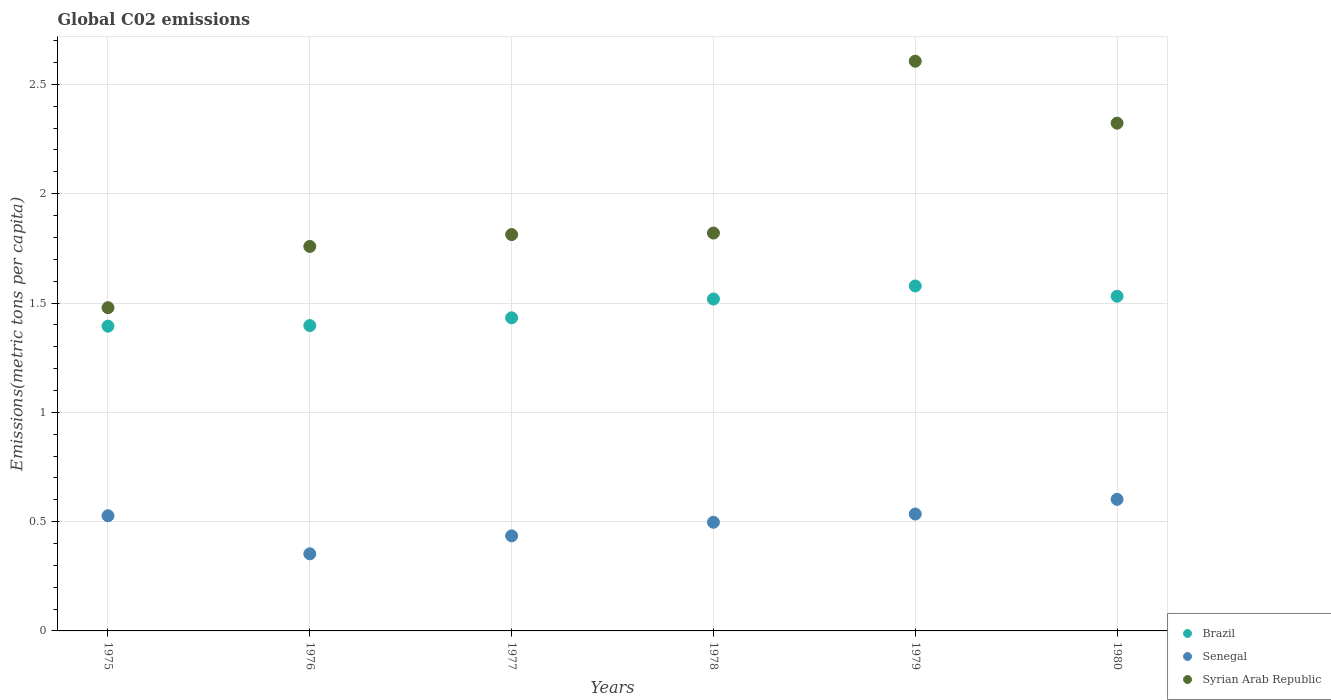How many different coloured dotlines are there?
Offer a very short reply. 3. Is the number of dotlines equal to the number of legend labels?
Offer a terse response. Yes. What is the amount of CO2 emitted in in Senegal in 1979?
Provide a short and direct response. 0.53. Across all years, what is the maximum amount of CO2 emitted in in Senegal?
Keep it short and to the point. 0.6. Across all years, what is the minimum amount of CO2 emitted in in Brazil?
Give a very brief answer. 1.39. In which year was the amount of CO2 emitted in in Senegal maximum?
Give a very brief answer. 1980. In which year was the amount of CO2 emitted in in Syrian Arab Republic minimum?
Your response must be concise. 1975. What is the total amount of CO2 emitted in in Syrian Arab Republic in the graph?
Offer a terse response. 11.8. What is the difference between the amount of CO2 emitted in in Syrian Arab Republic in 1976 and that in 1980?
Ensure brevity in your answer.  -0.56. What is the difference between the amount of CO2 emitted in in Senegal in 1975 and the amount of CO2 emitted in in Syrian Arab Republic in 1976?
Ensure brevity in your answer.  -1.23. What is the average amount of CO2 emitted in in Brazil per year?
Give a very brief answer. 1.48. In the year 1976, what is the difference between the amount of CO2 emitted in in Brazil and amount of CO2 emitted in in Senegal?
Give a very brief answer. 1.04. In how many years, is the amount of CO2 emitted in in Senegal greater than 2.4 metric tons per capita?
Your answer should be very brief. 0. What is the ratio of the amount of CO2 emitted in in Syrian Arab Republic in 1976 to that in 1978?
Offer a very short reply. 0.97. Is the difference between the amount of CO2 emitted in in Brazil in 1977 and 1980 greater than the difference between the amount of CO2 emitted in in Senegal in 1977 and 1980?
Make the answer very short. Yes. What is the difference between the highest and the second highest amount of CO2 emitted in in Syrian Arab Republic?
Your answer should be compact. 0.28. What is the difference between the highest and the lowest amount of CO2 emitted in in Syrian Arab Republic?
Offer a terse response. 1.13. In how many years, is the amount of CO2 emitted in in Senegal greater than the average amount of CO2 emitted in in Senegal taken over all years?
Offer a terse response. 4. Is the sum of the amount of CO2 emitted in in Brazil in 1976 and 1979 greater than the maximum amount of CO2 emitted in in Senegal across all years?
Ensure brevity in your answer.  Yes. Is it the case that in every year, the sum of the amount of CO2 emitted in in Brazil and amount of CO2 emitted in in Syrian Arab Republic  is greater than the amount of CO2 emitted in in Senegal?
Your response must be concise. Yes. What is the difference between two consecutive major ticks on the Y-axis?
Provide a short and direct response. 0.5. Are the values on the major ticks of Y-axis written in scientific E-notation?
Provide a succinct answer. No. What is the title of the graph?
Your response must be concise. Global C02 emissions. What is the label or title of the X-axis?
Offer a terse response. Years. What is the label or title of the Y-axis?
Make the answer very short. Emissions(metric tons per capita). What is the Emissions(metric tons per capita) in Brazil in 1975?
Your answer should be compact. 1.39. What is the Emissions(metric tons per capita) in Senegal in 1975?
Offer a terse response. 0.53. What is the Emissions(metric tons per capita) of Syrian Arab Republic in 1975?
Your answer should be compact. 1.48. What is the Emissions(metric tons per capita) of Brazil in 1976?
Make the answer very short. 1.4. What is the Emissions(metric tons per capita) of Senegal in 1976?
Provide a short and direct response. 0.35. What is the Emissions(metric tons per capita) of Syrian Arab Republic in 1976?
Your answer should be very brief. 1.76. What is the Emissions(metric tons per capita) in Brazil in 1977?
Provide a succinct answer. 1.43. What is the Emissions(metric tons per capita) in Senegal in 1977?
Offer a terse response. 0.43. What is the Emissions(metric tons per capita) of Syrian Arab Republic in 1977?
Give a very brief answer. 1.81. What is the Emissions(metric tons per capita) in Brazil in 1978?
Ensure brevity in your answer.  1.52. What is the Emissions(metric tons per capita) in Senegal in 1978?
Keep it short and to the point. 0.5. What is the Emissions(metric tons per capita) in Syrian Arab Republic in 1978?
Provide a succinct answer. 1.82. What is the Emissions(metric tons per capita) in Brazil in 1979?
Provide a succinct answer. 1.58. What is the Emissions(metric tons per capita) of Senegal in 1979?
Offer a very short reply. 0.53. What is the Emissions(metric tons per capita) of Syrian Arab Republic in 1979?
Provide a short and direct response. 2.61. What is the Emissions(metric tons per capita) in Brazil in 1980?
Ensure brevity in your answer.  1.53. What is the Emissions(metric tons per capita) of Senegal in 1980?
Offer a very short reply. 0.6. What is the Emissions(metric tons per capita) in Syrian Arab Republic in 1980?
Provide a short and direct response. 2.32. Across all years, what is the maximum Emissions(metric tons per capita) of Brazil?
Ensure brevity in your answer.  1.58. Across all years, what is the maximum Emissions(metric tons per capita) of Senegal?
Ensure brevity in your answer.  0.6. Across all years, what is the maximum Emissions(metric tons per capita) in Syrian Arab Republic?
Keep it short and to the point. 2.61. Across all years, what is the minimum Emissions(metric tons per capita) in Brazil?
Offer a terse response. 1.39. Across all years, what is the minimum Emissions(metric tons per capita) of Senegal?
Keep it short and to the point. 0.35. Across all years, what is the minimum Emissions(metric tons per capita) in Syrian Arab Republic?
Make the answer very short. 1.48. What is the total Emissions(metric tons per capita) in Brazil in the graph?
Give a very brief answer. 8.85. What is the total Emissions(metric tons per capita) of Senegal in the graph?
Your answer should be very brief. 2.95. What is the total Emissions(metric tons per capita) in Syrian Arab Republic in the graph?
Provide a short and direct response. 11.8. What is the difference between the Emissions(metric tons per capita) of Brazil in 1975 and that in 1976?
Give a very brief answer. -0. What is the difference between the Emissions(metric tons per capita) in Senegal in 1975 and that in 1976?
Offer a terse response. 0.17. What is the difference between the Emissions(metric tons per capita) of Syrian Arab Republic in 1975 and that in 1976?
Ensure brevity in your answer.  -0.28. What is the difference between the Emissions(metric tons per capita) in Brazil in 1975 and that in 1977?
Your answer should be compact. -0.04. What is the difference between the Emissions(metric tons per capita) of Senegal in 1975 and that in 1977?
Give a very brief answer. 0.09. What is the difference between the Emissions(metric tons per capita) in Syrian Arab Republic in 1975 and that in 1977?
Give a very brief answer. -0.33. What is the difference between the Emissions(metric tons per capita) in Brazil in 1975 and that in 1978?
Your answer should be very brief. -0.12. What is the difference between the Emissions(metric tons per capita) in Senegal in 1975 and that in 1978?
Provide a short and direct response. 0.03. What is the difference between the Emissions(metric tons per capita) in Syrian Arab Republic in 1975 and that in 1978?
Your answer should be compact. -0.34. What is the difference between the Emissions(metric tons per capita) of Brazil in 1975 and that in 1979?
Make the answer very short. -0.18. What is the difference between the Emissions(metric tons per capita) in Senegal in 1975 and that in 1979?
Your answer should be compact. -0.01. What is the difference between the Emissions(metric tons per capita) in Syrian Arab Republic in 1975 and that in 1979?
Keep it short and to the point. -1.13. What is the difference between the Emissions(metric tons per capita) in Brazil in 1975 and that in 1980?
Ensure brevity in your answer.  -0.14. What is the difference between the Emissions(metric tons per capita) in Senegal in 1975 and that in 1980?
Offer a very short reply. -0.08. What is the difference between the Emissions(metric tons per capita) in Syrian Arab Republic in 1975 and that in 1980?
Ensure brevity in your answer.  -0.84. What is the difference between the Emissions(metric tons per capita) in Brazil in 1976 and that in 1977?
Your answer should be very brief. -0.04. What is the difference between the Emissions(metric tons per capita) of Senegal in 1976 and that in 1977?
Offer a very short reply. -0.08. What is the difference between the Emissions(metric tons per capita) in Syrian Arab Republic in 1976 and that in 1977?
Keep it short and to the point. -0.05. What is the difference between the Emissions(metric tons per capita) in Brazil in 1976 and that in 1978?
Your response must be concise. -0.12. What is the difference between the Emissions(metric tons per capita) in Senegal in 1976 and that in 1978?
Your response must be concise. -0.14. What is the difference between the Emissions(metric tons per capita) in Syrian Arab Republic in 1976 and that in 1978?
Your response must be concise. -0.06. What is the difference between the Emissions(metric tons per capita) in Brazil in 1976 and that in 1979?
Make the answer very short. -0.18. What is the difference between the Emissions(metric tons per capita) of Senegal in 1976 and that in 1979?
Your answer should be compact. -0.18. What is the difference between the Emissions(metric tons per capita) of Syrian Arab Republic in 1976 and that in 1979?
Your answer should be very brief. -0.85. What is the difference between the Emissions(metric tons per capita) in Brazil in 1976 and that in 1980?
Your answer should be very brief. -0.13. What is the difference between the Emissions(metric tons per capita) of Senegal in 1976 and that in 1980?
Provide a succinct answer. -0.25. What is the difference between the Emissions(metric tons per capita) in Syrian Arab Republic in 1976 and that in 1980?
Offer a terse response. -0.56. What is the difference between the Emissions(metric tons per capita) in Brazil in 1977 and that in 1978?
Your answer should be compact. -0.09. What is the difference between the Emissions(metric tons per capita) of Senegal in 1977 and that in 1978?
Your answer should be very brief. -0.06. What is the difference between the Emissions(metric tons per capita) in Syrian Arab Republic in 1977 and that in 1978?
Ensure brevity in your answer.  -0.01. What is the difference between the Emissions(metric tons per capita) in Brazil in 1977 and that in 1979?
Keep it short and to the point. -0.15. What is the difference between the Emissions(metric tons per capita) in Senegal in 1977 and that in 1979?
Provide a succinct answer. -0.1. What is the difference between the Emissions(metric tons per capita) in Syrian Arab Republic in 1977 and that in 1979?
Your answer should be very brief. -0.79. What is the difference between the Emissions(metric tons per capita) in Brazil in 1977 and that in 1980?
Offer a very short reply. -0.1. What is the difference between the Emissions(metric tons per capita) in Senegal in 1977 and that in 1980?
Offer a terse response. -0.17. What is the difference between the Emissions(metric tons per capita) in Syrian Arab Republic in 1977 and that in 1980?
Offer a very short reply. -0.51. What is the difference between the Emissions(metric tons per capita) of Brazil in 1978 and that in 1979?
Your response must be concise. -0.06. What is the difference between the Emissions(metric tons per capita) of Senegal in 1978 and that in 1979?
Provide a short and direct response. -0.04. What is the difference between the Emissions(metric tons per capita) of Syrian Arab Republic in 1978 and that in 1979?
Your response must be concise. -0.79. What is the difference between the Emissions(metric tons per capita) of Brazil in 1978 and that in 1980?
Ensure brevity in your answer.  -0.01. What is the difference between the Emissions(metric tons per capita) of Senegal in 1978 and that in 1980?
Offer a terse response. -0.1. What is the difference between the Emissions(metric tons per capita) in Syrian Arab Republic in 1978 and that in 1980?
Keep it short and to the point. -0.5. What is the difference between the Emissions(metric tons per capita) of Brazil in 1979 and that in 1980?
Your response must be concise. 0.05. What is the difference between the Emissions(metric tons per capita) of Senegal in 1979 and that in 1980?
Give a very brief answer. -0.07. What is the difference between the Emissions(metric tons per capita) in Syrian Arab Republic in 1979 and that in 1980?
Keep it short and to the point. 0.28. What is the difference between the Emissions(metric tons per capita) of Brazil in 1975 and the Emissions(metric tons per capita) of Senegal in 1976?
Provide a short and direct response. 1.04. What is the difference between the Emissions(metric tons per capita) in Brazil in 1975 and the Emissions(metric tons per capita) in Syrian Arab Republic in 1976?
Give a very brief answer. -0.36. What is the difference between the Emissions(metric tons per capita) of Senegal in 1975 and the Emissions(metric tons per capita) of Syrian Arab Republic in 1976?
Give a very brief answer. -1.23. What is the difference between the Emissions(metric tons per capita) in Brazil in 1975 and the Emissions(metric tons per capita) in Senegal in 1977?
Make the answer very short. 0.96. What is the difference between the Emissions(metric tons per capita) of Brazil in 1975 and the Emissions(metric tons per capita) of Syrian Arab Republic in 1977?
Make the answer very short. -0.42. What is the difference between the Emissions(metric tons per capita) of Senegal in 1975 and the Emissions(metric tons per capita) of Syrian Arab Republic in 1977?
Offer a very short reply. -1.29. What is the difference between the Emissions(metric tons per capita) of Brazil in 1975 and the Emissions(metric tons per capita) of Senegal in 1978?
Offer a terse response. 0.9. What is the difference between the Emissions(metric tons per capita) of Brazil in 1975 and the Emissions(metric tons per capita) of Syrian Arab Republic in 1978?
Your response must be concise. -0.43. What is the difference between the Emissions(metric tons per capita) of Senegal in 1975 and the Emissions(metric tons per capita) of Syrian Arab Republic in 1978?
Your answer should be compact. -1.29. What is the difference between the Emissions(metric tons per capita) of Brazil in 1975 and the Emissions(metric tons per capita) of Senegal in 1979?
Give a very brief answer. 0.86. What is the difference between the Emissions(metric tons per capita) in Brazil in 1975 and the Emissions(metric tons per capita) in Syrian Arab Republic in 1979?
Keep it short and to the point. -1.21. What is the difference between the Emissions(metric tons per capita) in Senegal in 1975 and the Emissions(metric tons per capita) in Syrian Arab Republic in 1979?
Your response must be concise. -2.08. What is the difference between the Emissions(metric tons per capita) of Brazil in 1975 and the Emissions(metric tons per capita) of Senegal in 1980?
Ensure brevity in your answer.  0.79. What is the difference between the Emissions(metric tons per capita) of Brazil in 1975 and the Emissions(metric tons per capita) of Syrian Arab Republic in 1980?
Your answer should be very brief. -0.93. What is the difference between the Emissions(metric tons per capita) of Senegal in 1975 and the Emissions(metric tons per capita) of Syrian Arab Republic in 1980?
Your answer should be compact. -1.8. What is the difference between the Emissions(metric tons per capita) in Brazil in 1976 and the Emissions(metric tons per capita) in Senegal in 1977?
Offer a terse response. 0.96. What is the difference between the Emissions(metric tons per capita) in Brazil in 1976 and the Emissions(metric tons per capita) in Syrian Arab Republic in 1977?
Make the answer very short. -0.42. What is the difference between the Emissions(metric tons per capita) in Senegal in 1976 and the Emissions(metric tons per capita) in Syrian Arab Republic in 1977?
Give a very brief answer. -1.46. What is the difference between the Emissions(metric tons per capita) of Brazil in 1976 and the Emissions(metric tons per capita) of Senegal in 1978?
Provide a succinct answer. 0.9. What is the difference between the Emissions(metric tons per capita) in Brazil in 1976 and the Emissions(metric tons per capita) in Syrian Arab Republic in 1978?
Keep it short and to the point. -0.42. What is the difference between the Emissions(metric tons per capita) in Senegal in 1976 and the Emissions(metric tons per capita) in Syrian Arab Republic in 1978?
Your answer should be very brief. -1.47. What is the difference between the Emissions(metric tons per capita) in Brazil in 1976 and the Emissions(metric tons per capita) in Senegal in 1979?
Give a very brief answer. 0.86. What is the difference between the Emissions(metric tons per capita) in Brazil in 1976 and the Emissions(metric tons per capita) in Syrian Arab Republic in 1979?
Offer a terse response. -1.21. What is the difference between the Emissions(metric tons per capita) of Senegal in 1976 and the Emissions(metric tons per capita) of Syrian Arab Republic in 1979?
Ensure brevity in your answer.  -2.25. What is the difference between the Emissions(metric tons per capita) in Brazil in 1976 and the Emissions(metric tons per capita) in Senegal in 1980?
Your response must be concise. 0.8. What is the difference between the Emissions(metric tons per capita) of Brazil in 1976 and the Emissions(metric tons per capita) of Syrian Arab Republic in 1980?
Keep it short and to the point. -0.93. What is the difference between the Emissions(metric tons per capita) of Senegal in 1976 and the Emissions(metric tons per capita) of Syrian Arab Republic in 1980?
Your answer should be compact. -1.97. What is the difference between the Emissions(metric tons per capita) of Brazil in 1977 and the Emissions(metric tons per capita) of Senegal in 1978?
Give a very brief answer. 0.94. What is the difference between the Emissions(metric tons per capita) in Brazil in 1977 and the Emissions(metric tons per capita) in Syrian Arab Republic in 1978?
Your answer should be very brief. -0.39. What is the difference between the Emissions(metric tons per capita) in Senegal in 1977 and the Emissions(metric tons per capita) in Syrian Arab Republic in 1978?
Offer a very short reply. -1.39. What is the difference between the Emissions(metric tons per capita) in Brazil in 1977 and the Emissions(metric tons per capita) in Senegal in 1979?
Your response must be concise. 0.9. What is the difference between the Emissions(metric tons per capita) in Brazil in 1977 and the Emissions(metric tons per capita) in Syrian Arab Republic in 1979?
Make the answer very short. -1.17. What is the difference between the Emissions(metric tons per capita) of Senegal in 1977 and the Emissions(metric tons per capita) of Syrian Arab Republic in 1979?
Offer a very short reply. -2.17. What is the difference between the Emissions(metric tons per capita) in Brazil in 1977 and the Emissions(metric tons per capita) in Senegal in 1980?
Make the answer very short. 0.83. What is the difference between the Emissions(metric tons per capita) of Brazil in 1977 and the Emissions(metric tons per capita) of Syrian Arab Republic in 1980?
Give a very brief answer. -0.89. What is the difference between the Emissions(metric tons per capita) in Senegal in 1977 and the Emissions(metric tons per capita) in Syrian Arab Republic in 1980?
Offer a terse response. -1.89. What is the difference between the Emissions(metric tons per capita) in Brazil in 1978 and the Emissions(metric tons per capita) in Senegal in 1979?
Provide a succinct answer. 0.98. What is the difference between the Emissions(metric tons per capita) in Brazil in 1978 and the Emissions(metric tons per capita) in Syrian Arab Republic in 1979?
Your response must be concise. -1.09. What is the difference between the Emissions(metric tons per capita) of Senegal in 1978 and the Emissions(metric tons per capita) of Syrian Arab Republic in 1979?
Your answer should be very brief. -2.11. What is the difference between the Emissions(metric tons per capita) in Brazil in 1978 and the Emissions(metric tons per capita) in Senegal in 1980?
Make the answer very short. 0.92. What is the difference between the Emissions(metric tons per capita) in Brazil in 1978 and the Emissions(metric tons per capita) in Syrian Arab Republic in 1980?
Give a very brief answer. -0.8. What is the difference between the Emissions(metric tons per capita) of Senegal in 1978 and the Emissions(metric tons per capita) of Syrian Arab Republic in 1980?
Your answer should be compact. -1.83. What is the difference between the Emissions(metric tons per capita) of Brazil in 1979 and the Emissions(metric tons per capita) of Senegal in 1980?
Offer a terse response. 0.98. What is the difference between the Emissions(metric tons per capita) of Brazil in 1979 and the Emissions(metric tons per capita) of Syrian Arab Republic in 1980?
Your answer should be compact. -0.74. What is the difference between the Emissions(metric tons per capita) of Senegal in 1979 and the Emissions(metric tons per capita) of Syrian Arab Republic in 1980?
Keep it short and to the point. -1.79. What is the average Emissions(metric tons per capita) in Brazil per year?
Offer a terse response. 1.48. What is the average Emissions(metric tons per capita) of Senegal per year?
Offer a terse response. 0.49. What is the average Emissions(metric tons per capita) of Syrian Arab Republic per year?
Your answer should be very brief. 1.97. In the year 1975, what is the difference between the Emissions(metric tons per capita) of Brazil and Emissions(metric tons per capita) of Senegal?
Your response must be concise. 0.87. In the year 1975, what is the difference between the Emissions(metric tons per capita) in Brazil and Emissions(metric tons per capita) in Syrian Arab Republic?
Your response must be concise. -0.08. In the year 1975, what is the difference between the Emissions(metric tons per capita) in Senegal and Emissions(metric tons per capita) in Syrian Arab Republic?
Keep it short and to the point. -0.95. In the year 1976, what is the difference between the Emissions(metric tons per capita) in Brazil and Emissions(metric tons per capita) in Senegal?
Give a very brief answer. 1.04. In the year 1976, what is the difference between the Emissions(metric tons per capita) in Brazil and Emissions(metric tons per capita) in Syrian Arab Republic?
Ensure brevity in your answer.  -0.36. In the year 1976, what is the difference between the Emissions(metric tons per capita) in Senegal and Emissions(metric tons per capita) in Syrian Arab Republic?
Provide a succinct answer. -1.41. In the year 1977, what is the difference between the Emissions(metric tons per capita) of Brazil and Emissions(metric tons per capita) of Senegal?
Provide a succinct answer. 1. In the year 1977, what is the difference between the Emissions(metric tons per capita) in Brazil and Emissions(metric tons per capita) in Syrian Arab Republic?
Offer a terse response. -0.38. In the year 1977, what is the difference between the Emissions(metric tons per capita) in Senegal and Emissions(metric tons per capita) in Syrian Arab Republic?
Provide a succinct answer. -1.38. In the year 1978, what is the difference between the Emissions(metric tons per capita) in Brazil and Emissions(metric tons per capita) in Senegal?
Ensure brevity in your answer.  1.02. In the year 1978, what is the difference between the Emissions(metric tons per capita) of Brazil and Emissions(metric tons per capita) of Syrian Arab Republic?
Provide a succinct answer. -0.3. In the year 1978, what is the difference between the Emissions(metric tons per capita) of Senegal and Emissions(metric tons per capita) of Syrian Arab Republic?
Your response must be concise. -1.32. In the year 1979, what is the difference between the Emissions(metric tons per capita) of Brazil and Emissions(metric tons per capita) of Senegal?
Offer a very short reply. 1.04. In the year 1979, what is the difference between the Emissions(metric tons per capita) of Brazil and Emissions(metric tons per capita) of Syrian Arab Republic?
Your answer should be very brief. -1.03. In the year 1979, what is the difference between the Emissions(metric tons per capita) in Senegal and Emissions(metric tons per capita) in Syrian Arab Republic?
Make the answer very short. -2.07. In the year 1980, what is the difference between the Emissions(metric tons per capita) of Brazil and Emissions(metric tons per capita) of Senegal?
Ensure brevity in your answer.  0.93. In the year 1980, what is the difference between the Emissions(metric tons per capita) of Brazil and Emissions(metric tons per capita) of Syrian Arab Republic?
Offer a terse response. -0.79. In the year 1980, what is the difference between the Emissions(metric tons per capita) in Senegal and Emissions(metric tons per capita) in Syrian Arab Republic?
Offer a very short reply. -1.72. What is the ratio of the Emissions(metric tons per capita) of Brazil in 1975 to that in 1976?
Your response must be concise. 1. What is the ratio of the Emissions(metric tons per capita) of Senegal in 1975 to that in 1976?
Make the answer very short. 1.49. What is the ratio of the Emissions(metric tons per capita) of Syrian Arab Republic in 1975 to that in 1976?
Offer a very short reply. 0.84. What is the ratio of the Emissions(metric tons per capita) in Brazil in 1975 to that in 1977?
Your response must be concise. 0.97. What is the ratio of the Emissions(metric tons per capita) of Senegal in 1975 to that in 1977?
Your response must be concise. 1.21. What is the ratio of the Emissions(metric tons per capita) of Syrian Arab Republic in 1975 to that in 1977?
Provide a succinct answer. 0.82. What is the ratio of the Emissions(metric tons per capita) of Brazil in 1975 to that in 1978?
Make the answer very short. 0.92. What is the ratio of the Emissions(metric tons per capita) in Senegal in 1975 to that in 1978?
Provide a short and direct response. 1.06. What is the ratio of the Emissions(metric tons per capita) of Syrian Arab Republic in 1975 to that in 1978?
Your response must be concise. 0.81. What is the ratio of the Emissions(metric tons per capita) in Brazil in 1975 to that in 1979?
Ensure brevity in your answer.  0.88. What is the ratio of the Emissions(metric tons per capita) of Senegal in 1975 to that in 1979?
Offer a very short reply. 0.99. What is the ratio of the Emissions(metric tons per capita) in Syrian Arab Republic in 1975 to that in 1979?
Offer a very short reply. 0.57. What is the ratio of the Emissions(metric tons per capita) in Brazil in 1975 to that in 1980?
Give a very brief answer. 0.91. What is the ratio of the Emissions(metric tons per capita) of Senegal in 1975 to that in 1980?
Give a very brief answer. 0.88. What is the ratio of the Emissions(metric tons per capita) in Syrian Arab Republic in 1975 to that in 1980?
Your answer should be very brief. 0.64. What is the ratio of the Emissions(metric tons per capita) in Brazil in 1976 to that in 1977?
Provide a succinct answer. 0.98. What is the ratio of the Emissions(metric tons per capita) of Senegal in 1976 to that in 1977?
Provide a succinct answer. 0.81. What is the ratio of the Emissions(metric tons per capita) in Syrian Arab Republic in 1976 to that in 1977?
Give a very brief answer. 0.97. What is the ratio of the Emissions(metric tons per capita) of Senegal in 1976 to that in 1978?
Give a very brief answer. 0.71. What is the ratio of the Emissions(metric tons per capita) in Syrian Arab Republic in 1976 to that in 1978?
Your answer should be compact. 0.97. What is the ratio of the Emissions(metric tons per capita) in Brazil in 1976 to that in 1979?
Your answer should be compact. 0.89. What is the ratio of the Emissions(metric tons per capita) in Senegal in 1976 to that in 1979?
Provide a succinct answer. 0.66. What is the ratio of the Emissions(metric tons per capita) of Syrian Arab Republic in 1976 to that in 1979?
Offer a terse response. 0.67. What is the ratio of the Emissions(metric tons per capita) in Brazil in 1976 to that in 1980?
Your answer should be very brief. 0.91. What is the ratio of the Emissions(metric tons per capita) in Senegal in 1976 to that in 1980?
Make the answer very short. 0.59. What is the ratio of the Emissions(metric tons per capita) of Syrian Arab Republic in 1976 to that in 1980?
Offer a very short reply. 0.76. What is the ratio of the Emissions(metric tons per capita) of Brazil in 1977 to that in 1978?
Provide a short and direct response. 0.94. What is the ratio of the Emissions(metric tons per capita) in Senegal in 1977 to that in 1978?
Your answer should be very brief. 0.87. What is the ratio of the Emissions(metric tons per capita) in Syrian Arab Republic in 1977 to that in 1978?
Provide a succinct answer. 1. What is the ratio of the Emissions(metric tons per capita) of Brazil in 1977 to that in 1979?
Ensure brevity in your answer.  0.91. What is the ratio of the Emissions(metric tons per capita) of Senegal in 1977 to that in 1979?
Offer a terse response. 0.81. What is the ratio of the Emissions(metric tons per capita) in Syrian Arab Republic in 1977 to that in 1979?
Provide a succinct answer. 0.7. What is the ratio of the Emissions(metric tons per capita) of Brazil in 1977 to that in 1980?
Ensure brevity in your answer.  0.94. What is the ratio of the Emissions(metric tons per capita) of Senegal in 1977 to that in 1980?
Your answer should be compact. 0.72. What is the ratio of the Emissions(metric tons per capita) in Syrian Arab Republic in 1977 to that in 1980?
Provide a succinct answer. 0.78. What is the ratio of the Emissions(metric tons per capita) of Brazil in 1978 to that in 1979?
Provide a short and direct response. 0.96. What is the ratio of the Emissions(metric tons per capita) of Senegal in 1978 to that in 1979?
Offer a terse response. 0.93. What is the ratio of the Emissions(metric tons per capita) of Syrian Arab Republic in 1978 to that in 1979?
Your answer should be very brief. 0.7. What is the ratio of the Emissions(metric tons per capita) in Senegal in 1978 to that in 1980?
Offer a terse response. 0.83. What is the ratio of the Emissions(metric tons per capita) in Syrian Arab Republic in 1978 to that in 1980?
Keep it short and to the point. 0.78. What is the ratio of the Emissions(metric tons per capita) of Brazil in 1979 to that in 1980?
Ensure brevity in your answer.  1.03. What is the ratio of the Emissions(metric tons per capita) in Senegal in 1979 to that in 1980?
Offer a very short reply. 0.89. What is the ratio of the Emissions(metric tons per capita) in Syrian Arab Republic in 1979 to that in 1980?
Your response must be concise. 1.12. What is the difference between the highest and the second highest Emissions(metric tons per capita) in Brazil?
Provide a short and direct response. 0.05. What is the difference between the highest and the second highest Emissions(metric tons per capita) in Senegal?
Make the answer very short. 0.07. What is the difference between the highest and the second highest Emissions(metric tons per capita) in Syrian Arab Republic?
Ensure brevity in your answer.  0.28. What is the difference between the highest and the lowest Emissions(metric tons per capita) of Brazil?
Give a very brief answer. 0.18. What is the difference between the highest and the lowest Emissions(metric tons per capita) of Senegal?
Make the answer very short. 0.25. What is the difference between the highest and the lowest Emissions(metric tons per capita) in Syrian Arab Republic?
Provide a short and direct response. 1.13. 